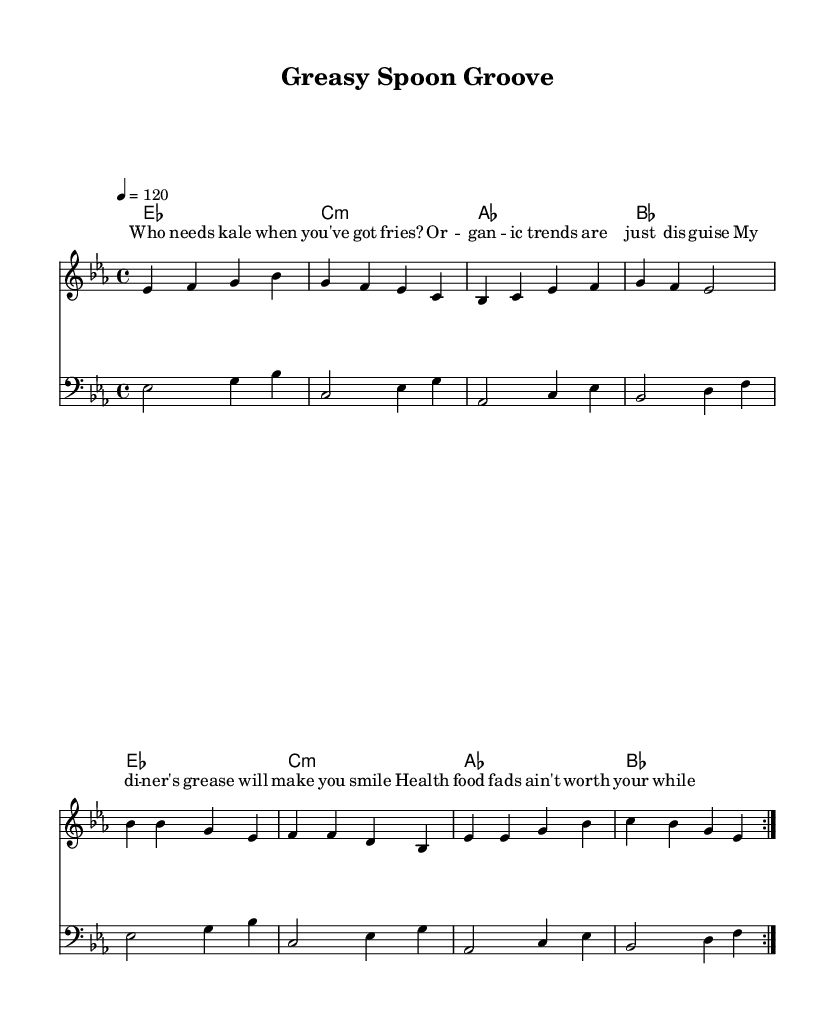What is the key signature of this music? The key signature shown at the beginning of the sheet music is E-flat major, which contains three flats. These flats are B-flat, E-flat, and A-flat. This defines the notes that will sound flat throughout the piece unless otherwise marked.
Answer: E-flat major What is the time signature of this music? The time signature located at the beginning of the sheet music indicates that there are four beats in each measure, with the quarter note receiving one beat. This is indicated by the "4/4" notation.
Answer: 4/4 What is the tempo marking for this piece? The tempo marking indicated in the score states "4 = 120". This indicates that the quarter note should be played at a speed of 120 beats per minute, setting a moderate tempo for the piece.
Answer: 120 How many measures are repeated in this score? The instruction to repeat sections is indicated by "repeat volta 2". This means that the entire section is played twice, effectively doubling the number of measures played from that section.
Answer: 2 What is the title of this piece? The title is provided at the top of the sheet music under the header and states the piece's name. It provides insight into the theme of the song, tying it to the topic it discusses.
Answer: Greasy Spoon Groove What instrument is the bass line written for? The clef notation shown at the beginning of the bass line staff indicates that it is written in bass clef, which is commonly used for lower-pitched instruments or voices.
Answer: Bass What type of food does this tune criticize? The lyrics indicate a clear reference to 'health food fads', implying that the song expresses criticism toward these modern dietary trends. The lyrics emphasize traditional greasy foods as a preferable choice.
Answer: Health food fads 